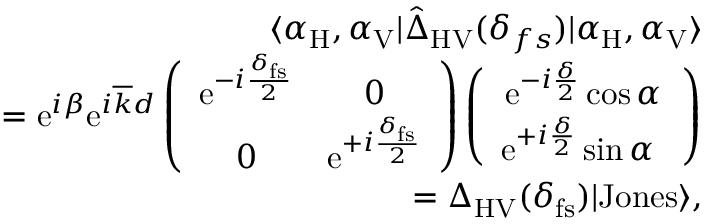<formula> <loc_0><loc_0><loc_500><loc_500>\begin{array} { r l r } & { \langle \alpha _ { H } , \alpha _ { V } | \hat { \Delta } _ { H V } ( \delta _ { f s } ) | \alpha _ { H } , \alpha _ { V } \rangle } \\ & { = e ^ { i \beta } e ^ { i \overline { k } d } \left ( \begin{array} { c c } { e ^ { - i \frac { \delta _ { f s } } { 2 } } } & { 0 } \\ { 0 } & { e ^ { + i \frac { \delta _ { f s } } { 2 } } } \end{array} \right ) \left ( \begin{array} { c } { e ^ { - i \frac { \delta } { 2 } } \cos \alpha } \\ { e ^ { + i \frac { \delta } { 2 } } \sin \alpha \ } \end{array} \right ) } \\ & { = \Delta _ { H V } ( \delta _ { f s } ) | J o n e s \rangle , } \end{array}</formula> 